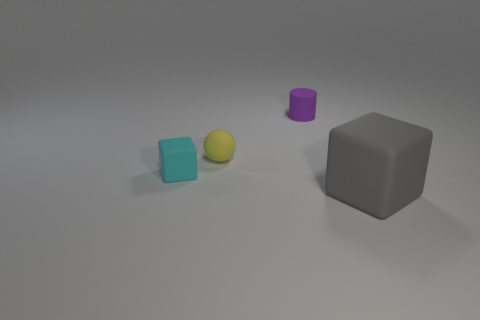What is the size of the gray cube that is the same material as the small purple cylinder?
Your answer should be very brief. Large. The purple matte thing behind the matte block that is on the left side of the tiny matte cylinder is what shape?
Your response must be concise. Cylinder. There is a matte object that is both left of the small purple rubber cylinder and behind the cyan thing; what size is it?
Your answer should be very brief. Small. Is there a blue matte object that has the same shape as the gray rubber thing?
Give a very brief answer. No. Are there any other things that are the same shape as the big gray object?
Make the answer very short. Yes. There is a block that is on the left side of the cube that is in front of the cube that is behind the big gray block; what is its material?
Offer a terse response. Rubber. Is there a green thing that has the same size as the cyan matte thing?
Your response must be concise. No. There is a cube to the left of the small matte object behind the small rubber ball; what color is it?
Provide a short and direct response. Cyan. What number of tiny yellow rubber spheres are there?
Provide a succinct answer. 1. Is the color of the sphere the same as the tiny rubber cylinder?
Offer a very short reply. No. 